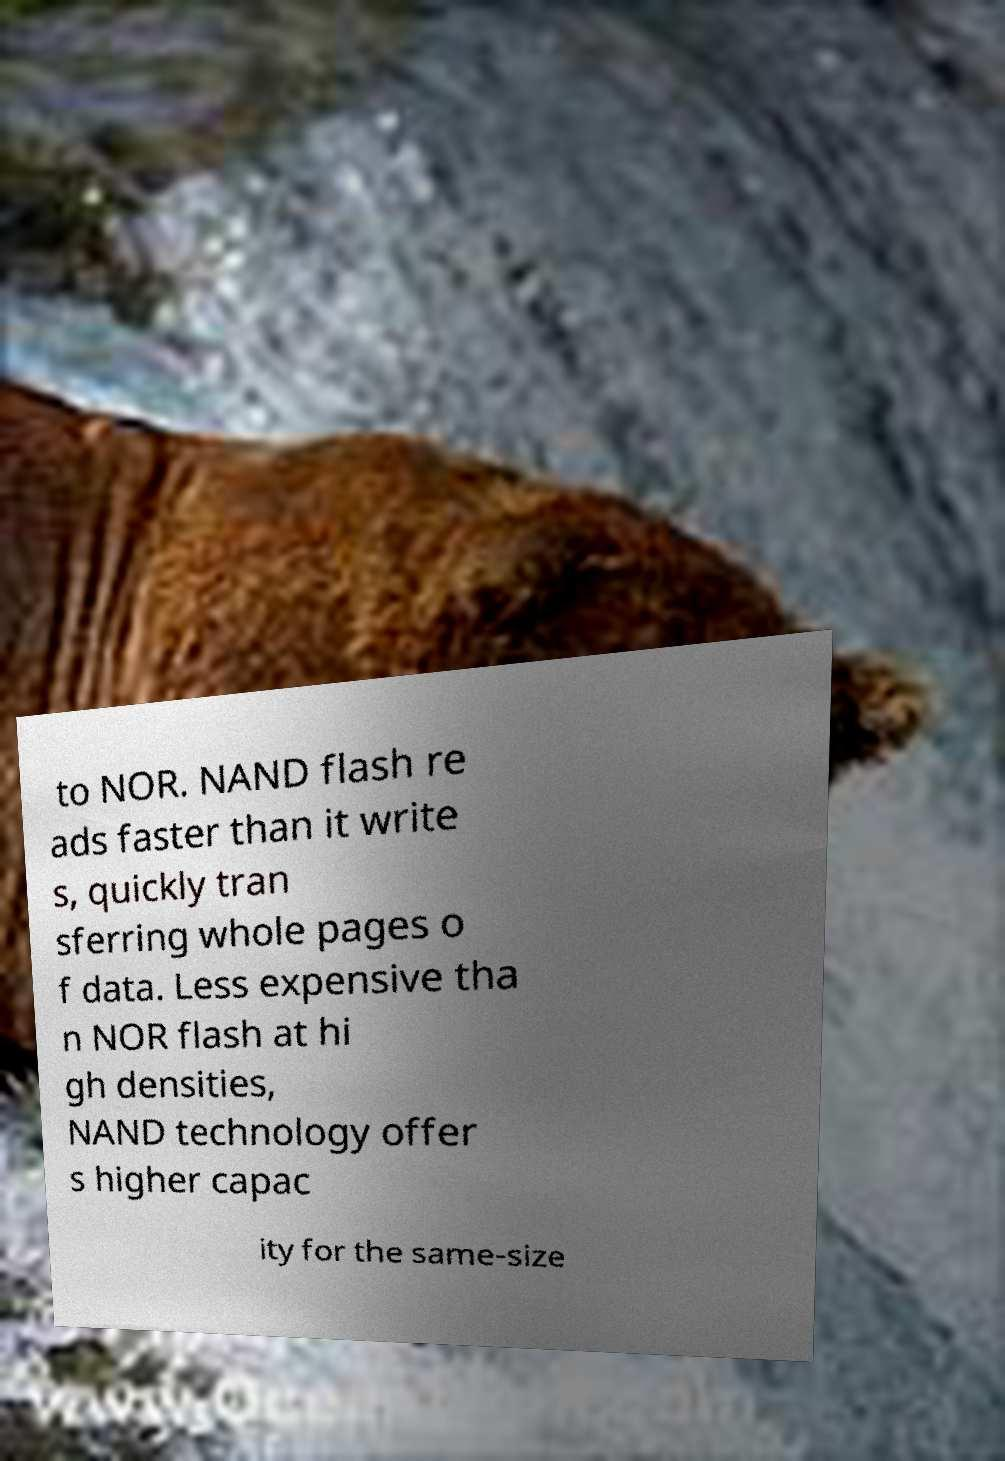For documentation purposes, I need the text within this image transcribed. Could you provide that? to NOR. NAND flash re ads faster than it write s, quickly tran sferring whole pages o f data. Less expensive tha n NOR flash at hi gh densities, NAND technology offer s higher capac ity for the same-size 